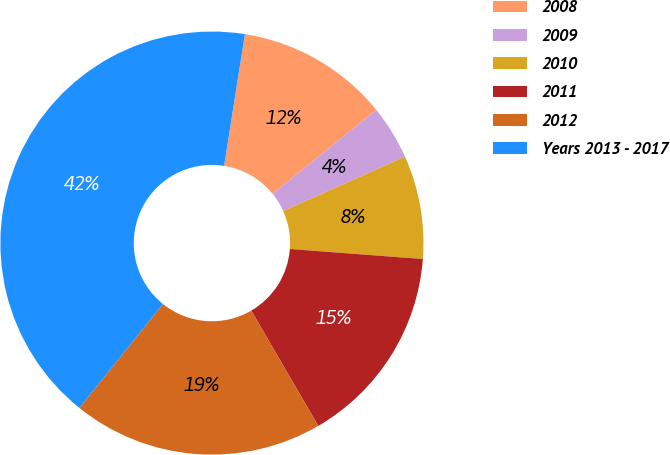Convert chart to OTSL. <chart><loc_0><loc_0><loc_500><loc_500><pie_chart><fcel>2008<fcel>2009<fcel>2010<fcel>2011<fcel>2012<fcel>Years 2013 - 2017<nl><fcel>11.66%<fcel>4.15%<fcel>7.9%<fcel>15.41%<fcel>19.17%<fcel>41.71%<nl></chart> 